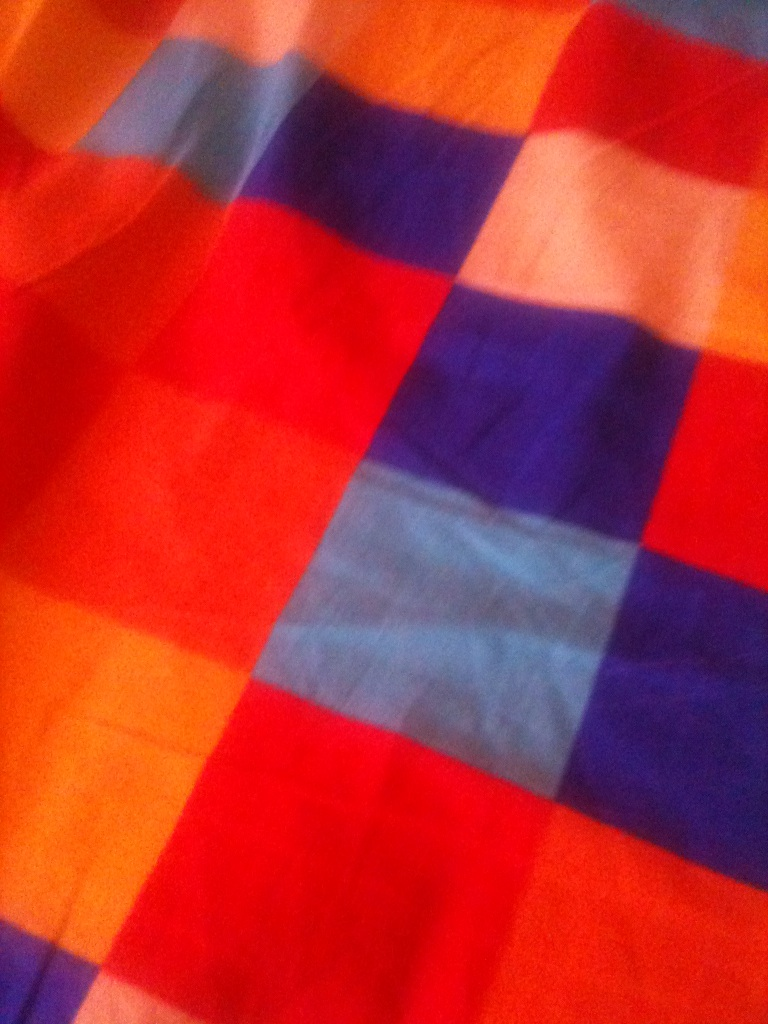What practical applications might this fabric have? This colorful fabric could be used for various practical purposes around the home and in fashion. For instance, it would make eye-catching tablecloths, curtains, or pillowcases, bringing a bright and cheerful atmosphere to any room. In fashion, it could be crafted into stylish clothing items, such as shirts, skirts, or dresses, providing a burst of color and unique design. It could also be perfect for accessories like bags or headscarves, adding a vibrant touch to everyday outfits. 